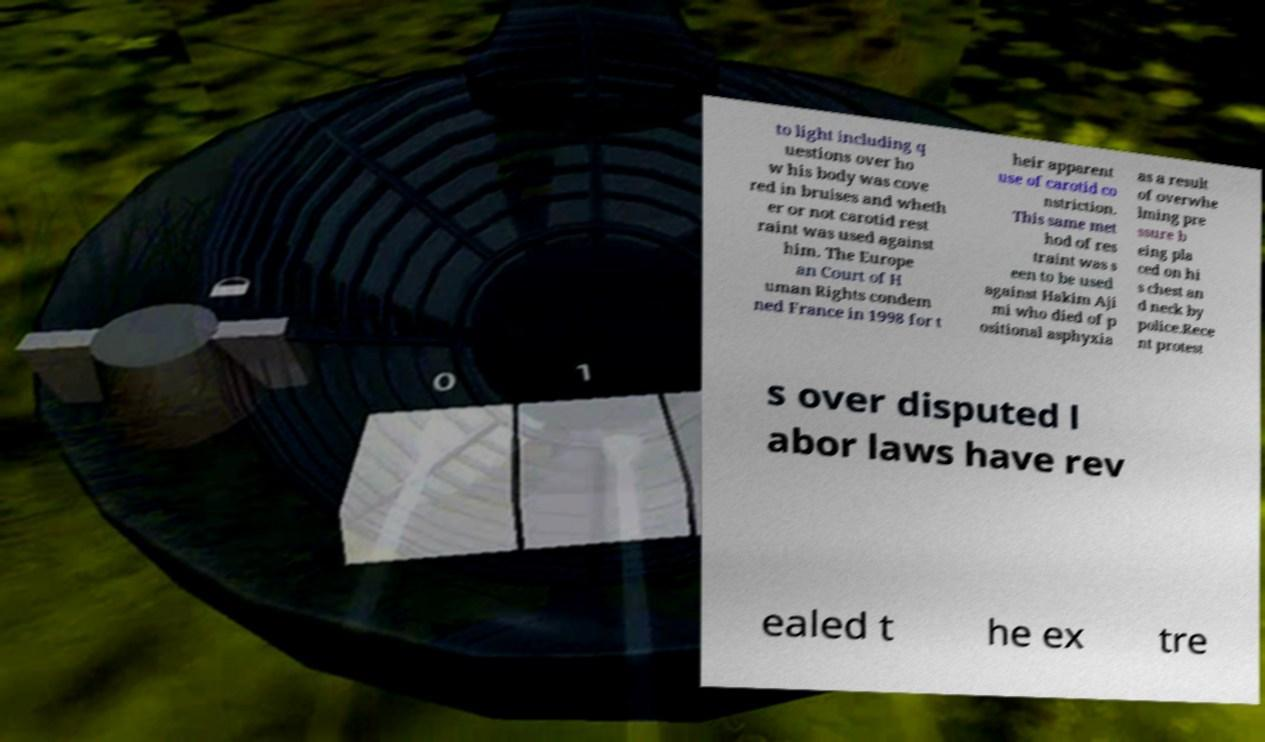I need the written content from this picture converted into text. Can you do that? to light including q uestions over ho w his body was cove red in bruises and wheth er or not carotid rest raint was used against him. The Europe an Court of H uman Rights condem ned France in 1998 for t heir apparent use of carotid co nstriction. This same met hod of res traint was s een to be used against Hakim Aji mi who died of p ositional asphyxia as a result of overwhe lming pre ssure b eing pla ced on hi s chest an d neck by police.Rece nt protest s over disputed l abor laws have rev ealed t he ex tre 